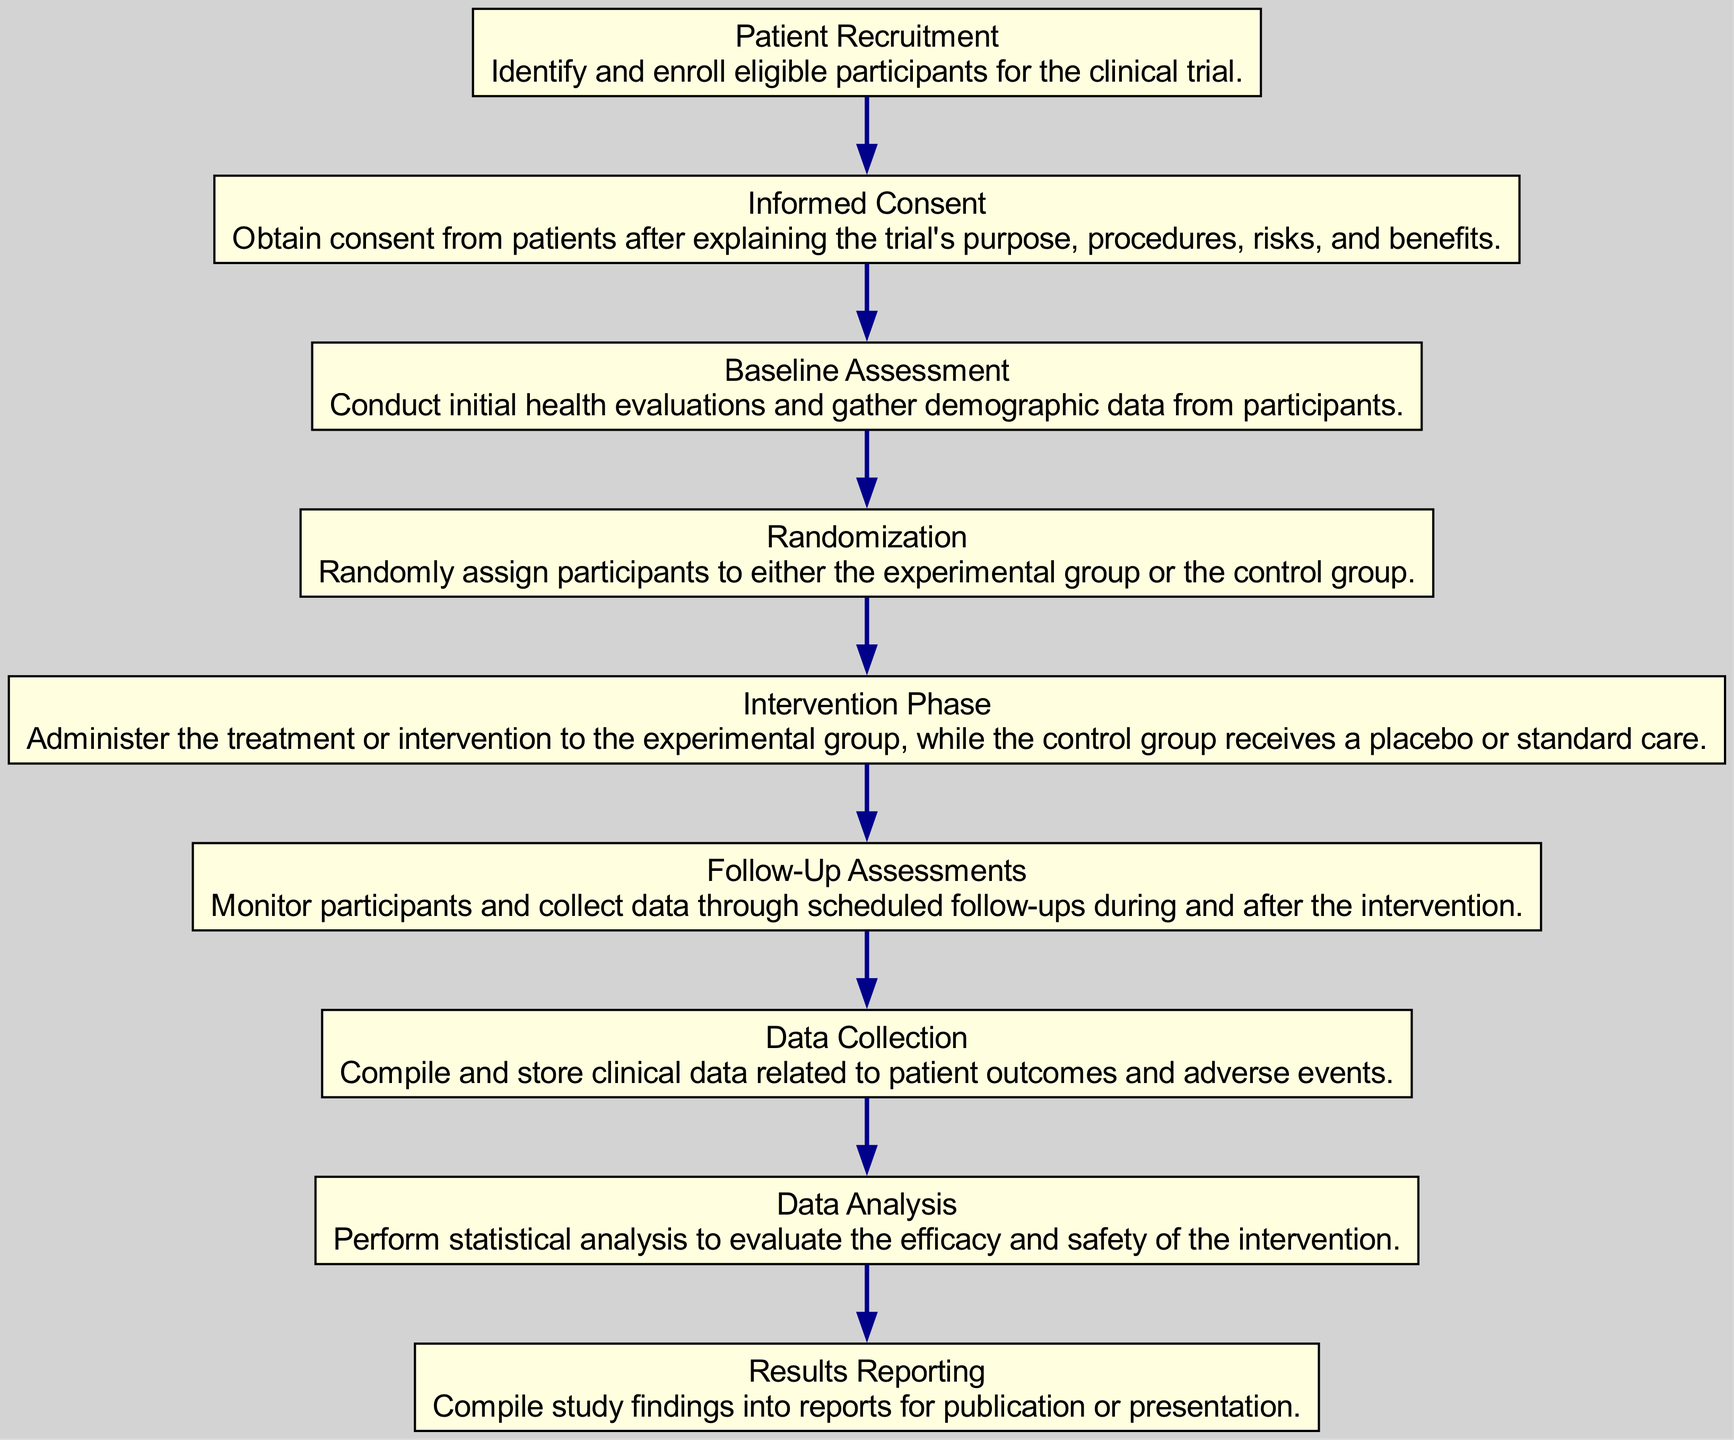What is the first step in the clinical trial process? The diagram indicates that the first step is "Patient Recruitment," where eligible participants are identified and enrolled in the clinical trial.
Answer: Patient Recruitment How many total steps are represented in the diagram? By counting the nodes, there are nine distinct steps outlined in the clinical trial process from recruitment to data analysis.
Answer: 9 What step follows the "Informed Consent"? Looking at the sequence of the steps, "Baseline Assessment" directly follows "Informed Consent," where initial evaluations are conducted.
Answer: Baseline Assessment Which step describes the phase where participants receive treatment? The diagram shows "Intervention Phase" as the part where the treatment is administered to the experimental group, while the control group receives placebo or standard care.
Answer: Intervention Phase What is the last step in the clinical trial process? The final step as per the flow of the diagram is "Results Reporting," which entails compiling study findings into reports for publication or presentation.
Answer: Results Reporting Which two steps are directly connected to the "Randomization" step? The steps "Baseline Assessment" precedes "Randomization," and "Intervention Phase" follows "Randomization," indicating a clear flow from enrolling participants to assigning them to groups.
Answer: Baseline Assessment, Intervention Phase During which step is data collected regarding patient outcomes and adverse events? The diagram highlights "Data Collection" as the stage where clinical data about patient outcomes and adverse events is compiled and stored.
Answer: Data Collection What does the step "Follow-Up Assessments" involve? This step involves monitoring participants and collecting further data through scheduled follow-ups during and after the intervention, ensuring ongoing data acquisition.
Answer: Monitoring participants How does the "Data Analysis" step relate to the entire process? "Data Analysis" is critical as it follows data collection and involves performing statistical analysis to assess the efficacy and safety of the intervention, thereby determining the trial's success.
Answer: Statistical analysis 